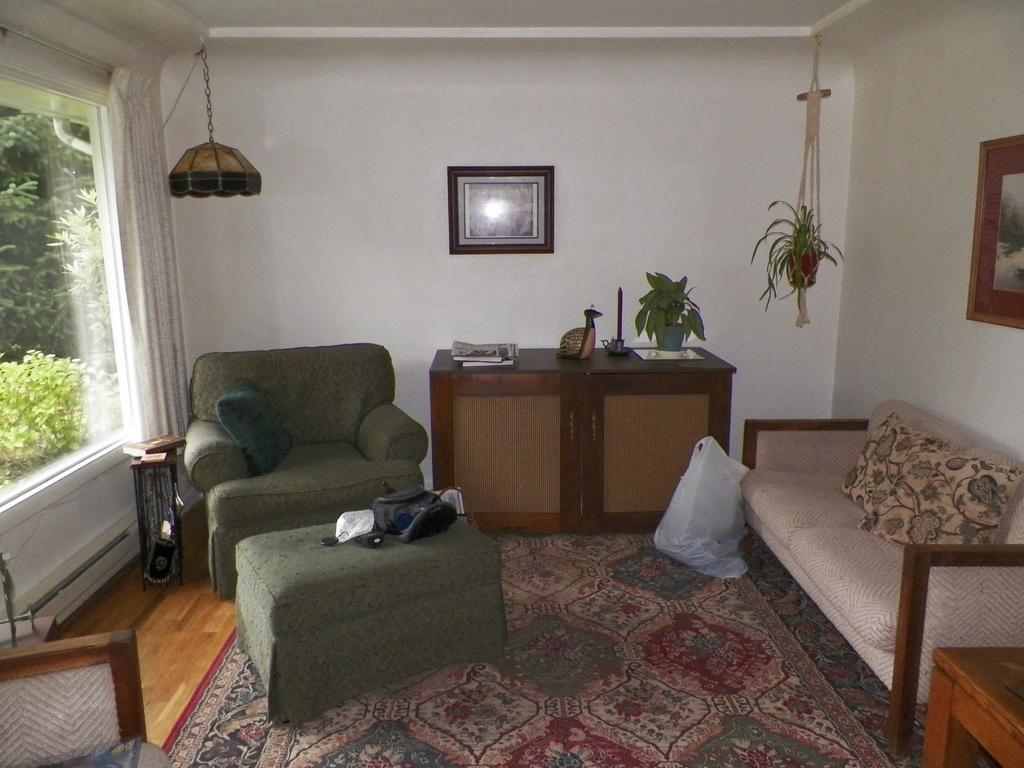Please provide a concise description of this image. The image is taken in the room. In the center of the image there is a table there are books, decor and a plant placed on the table. On the right there is a sofa and cushions placed on the sofa. On the left there is a couch. In the background there are wall frames which are attached to the walls. We can see a window and a curtain. 